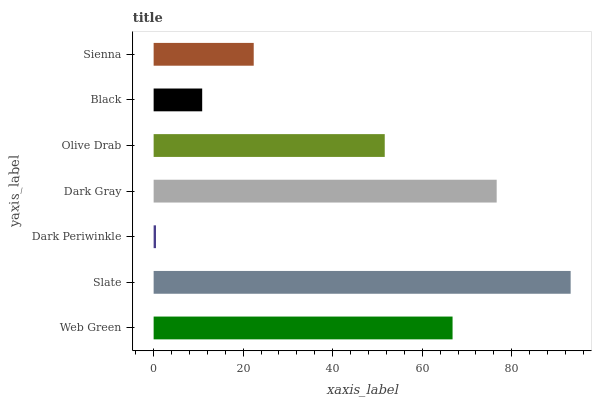Is Dark Periwinkle the minimum?
Answer yes or no. Yes. Is Slate the maximum?
Answer yes or no. Yes. Is Slate the minimum?
Answer yes or no. No. Is Dark Periwinkle the maximum?
Answer yes or no. No. Is Slate greater than Dark Periwinkle?
Answer yes or no. Yes. Is Dark Periwinkle less than Slate?
Answer yes or no. Yes. Is Dark Periwinkle greater than Slate?
Answer yes or no. No. Is Slate less than Dark Periwinkle?
Answer yes or no. No. Is Olive Drab the high median?
Answer yes or no. Yes. Is Olive Drab the low median?
Answer yes or no. Yes. Is Dark Gray the high median?
Answer yes or no. No. Is Web Green the low median?
Answer yes or no. No. 